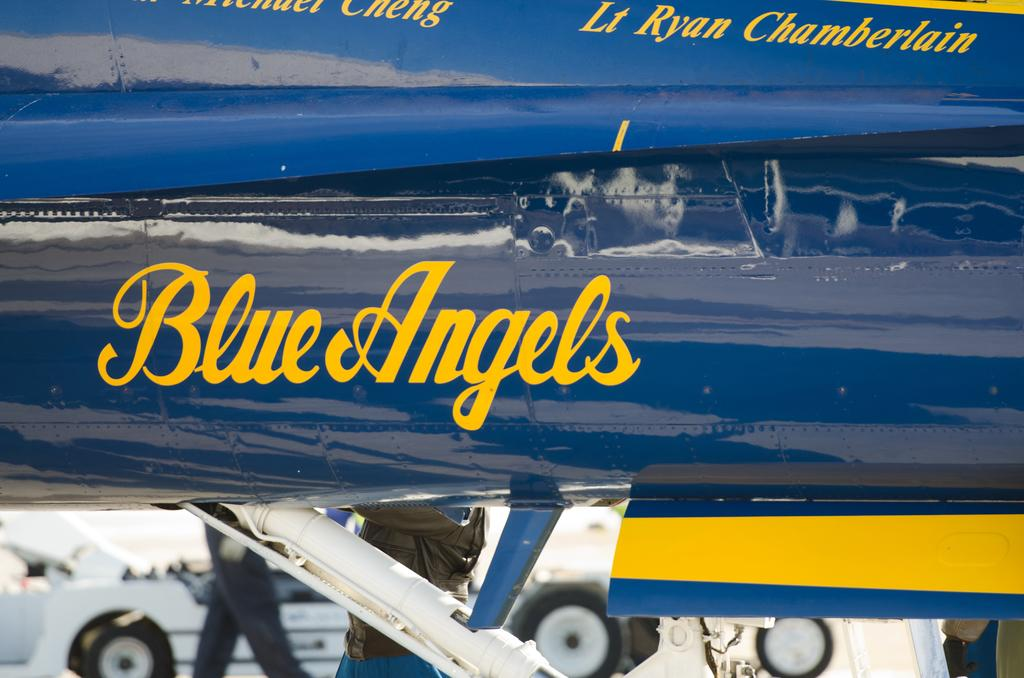<image>
Present a compact description of the photo's key features. A close up of a Blue Angels Airplane logo with a person walking. 